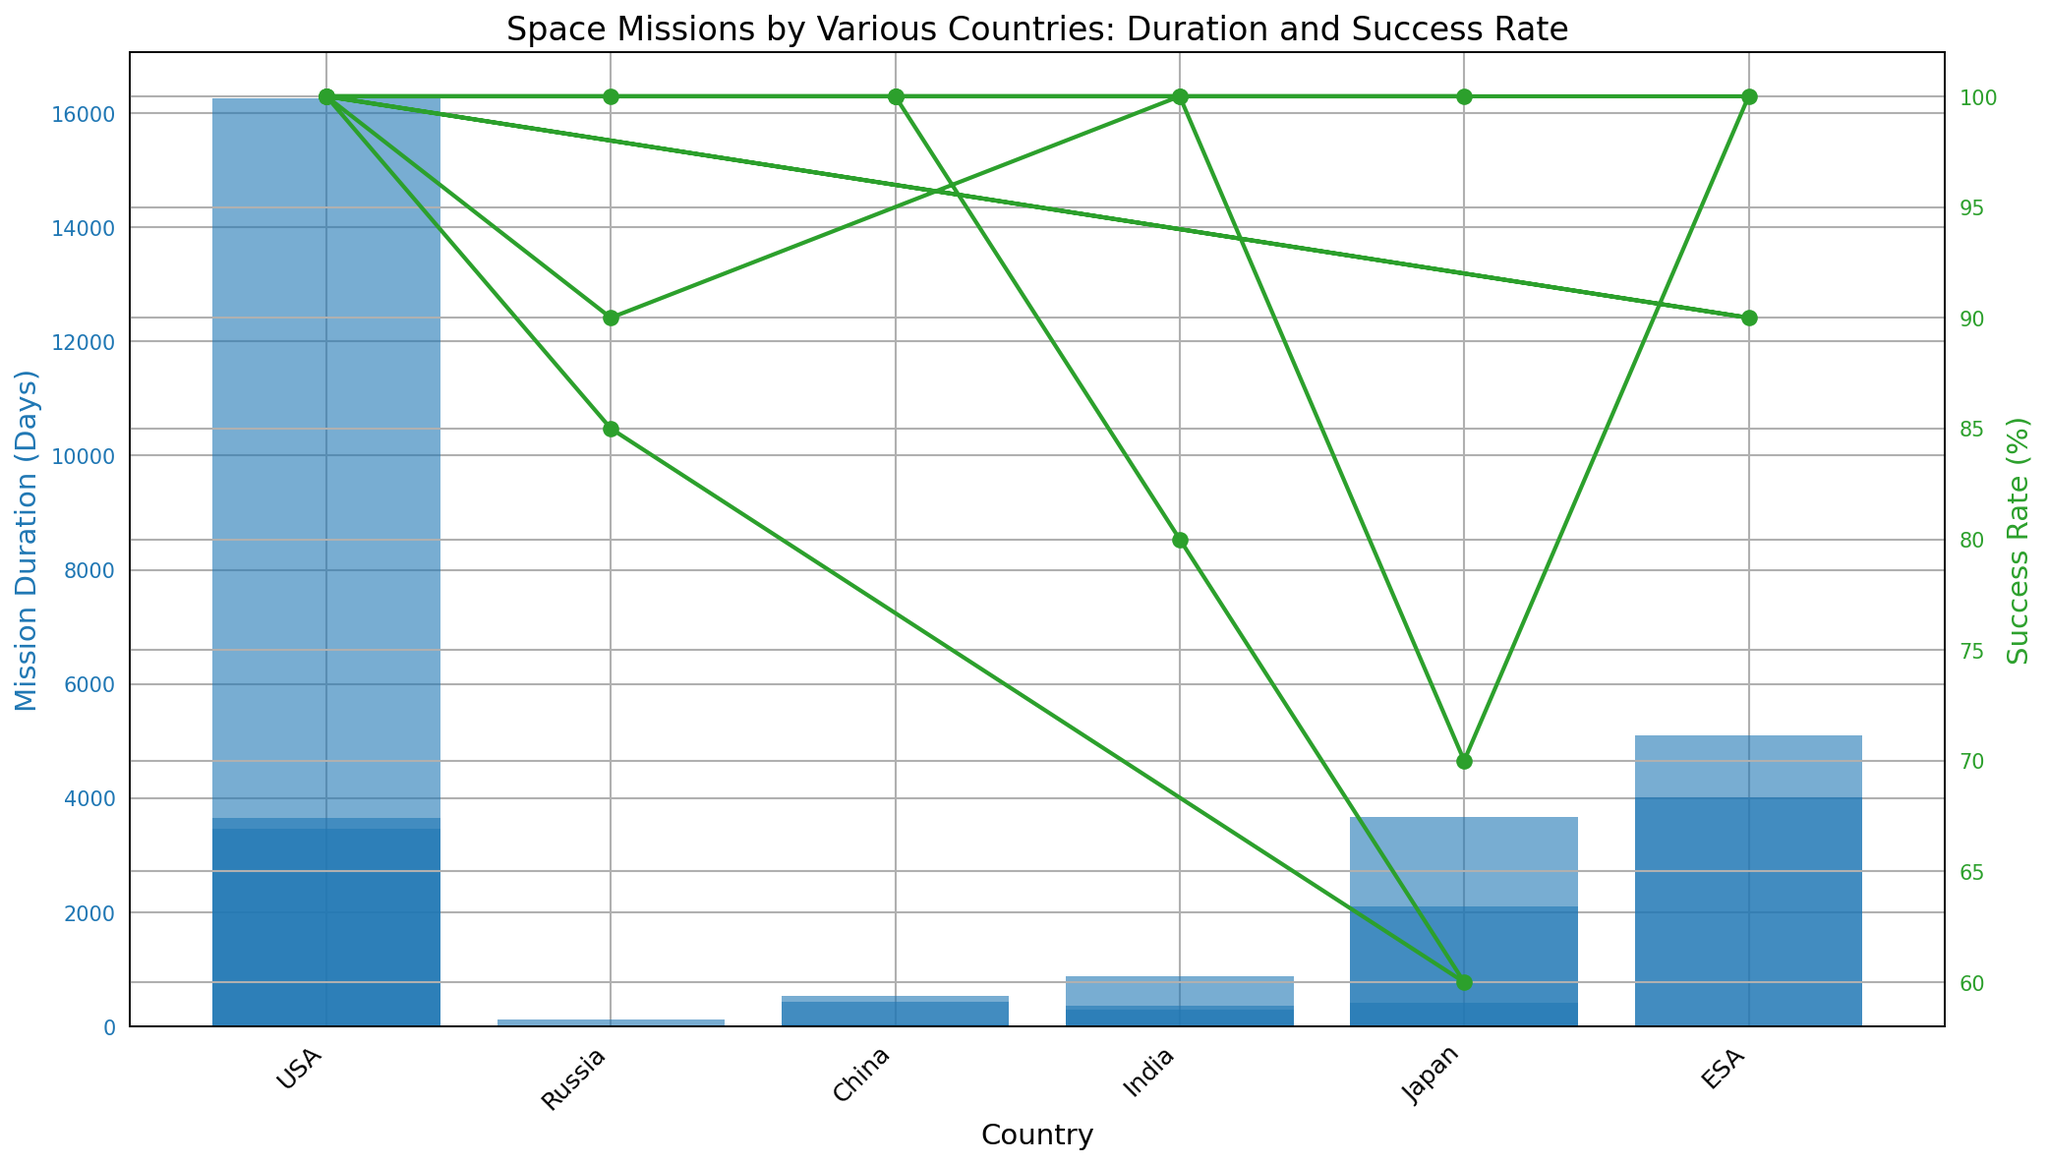What's the longest mission duration among all the countries? To find the longest mission duration, look for the tallest blue bar in the figure, which represents the mission durations in days. The tallest bar corresponds to the USA's Voyager 1 with a duration of 16,257 days.
Answer: 16,257 days Which mission has the highest success rate, and what country does it belong to? Check for the green line that reaches the top of the 100% mark. Multiple missions have a 100% success rate, such as Apoll0 11 (USA), Luna 2 (Russia), and Chang'e 4 (China). To specifically identify one, just pick any of these.
Answer: Apoll0 11, USA Compare the mission durations of India's Mangalyaan and Chandrayaan-2. Is one significantly longer than the other? Look at the blue bars representing India's Mangalyaan and Chandrayaan-2. Mangalyaan has a duration of 300 days and Chandrayaan-2 has 876 days. The difference is (876 - 300) = 576 days. Chandrayaan-2 is significantly longer.
Answer: Chandrayaan-2 is longer by 576 days What's the average mission duration for missions by Japan? Locate the blue bars corresponding to Japanese missions: Hiten (423 days), Hayabusa (2101 days), and Akatsuki (3674 days). Calculate the average: (423 + 2101 + 3674) / 3 ≈ 2066 days.
Answer: 2066 days How many missions have a success rate less than 100%? Observe the green line's markers. The missions below 100% are Japan's Hiten (70%), Russia's Venera 7 (85%), and Russia's Soyuz T-10 (90%). Count these occurrences for a total count.
Answer: 3 missions Which country has the most varied mission durations, and what are the shortest and longest durations? Compare the heights of the blue bars for each country. USA's mission durations range from 5 days (Soyuz T-10) to 16,257 days (Voyager 1).
Answer: USA, 5 days to 16,257 days Does any mission have a duration close to 1 year and a success rate of 100%? Check the blue bars near 365 days and see the corresponding green line. India's PSLV-C37 has 365 days duration and a 100% success rate.
Answer: PSLV-C37 What is the smallest mission duration among all the countries, and what was the success rate? Identify the shortest blue bar, which is Russia's Luna 2 with a duration of 1 day. The green line indicates a success rate of 100%.
Answer: Luna 2, 1 day, 100% Compare and rank the success rates of the space missions by Japan. Identify the markers on the green line for Japanese missions: Hiten (70%), Hayabusa (60%), and Akatsuki (100%). Rank them in ascending order: Hayabusa, Hiten, Akatsuki.
Answer: Hayabusa < Hiten < Akatsuki Which mission had almost the same duration as the USA's New Horizons but from a different country? Find the blue bar for USA's New Horizons (3462 days). The nearest is Japan's Akatsuki at 3674 days.
Answer: Akatsuki 